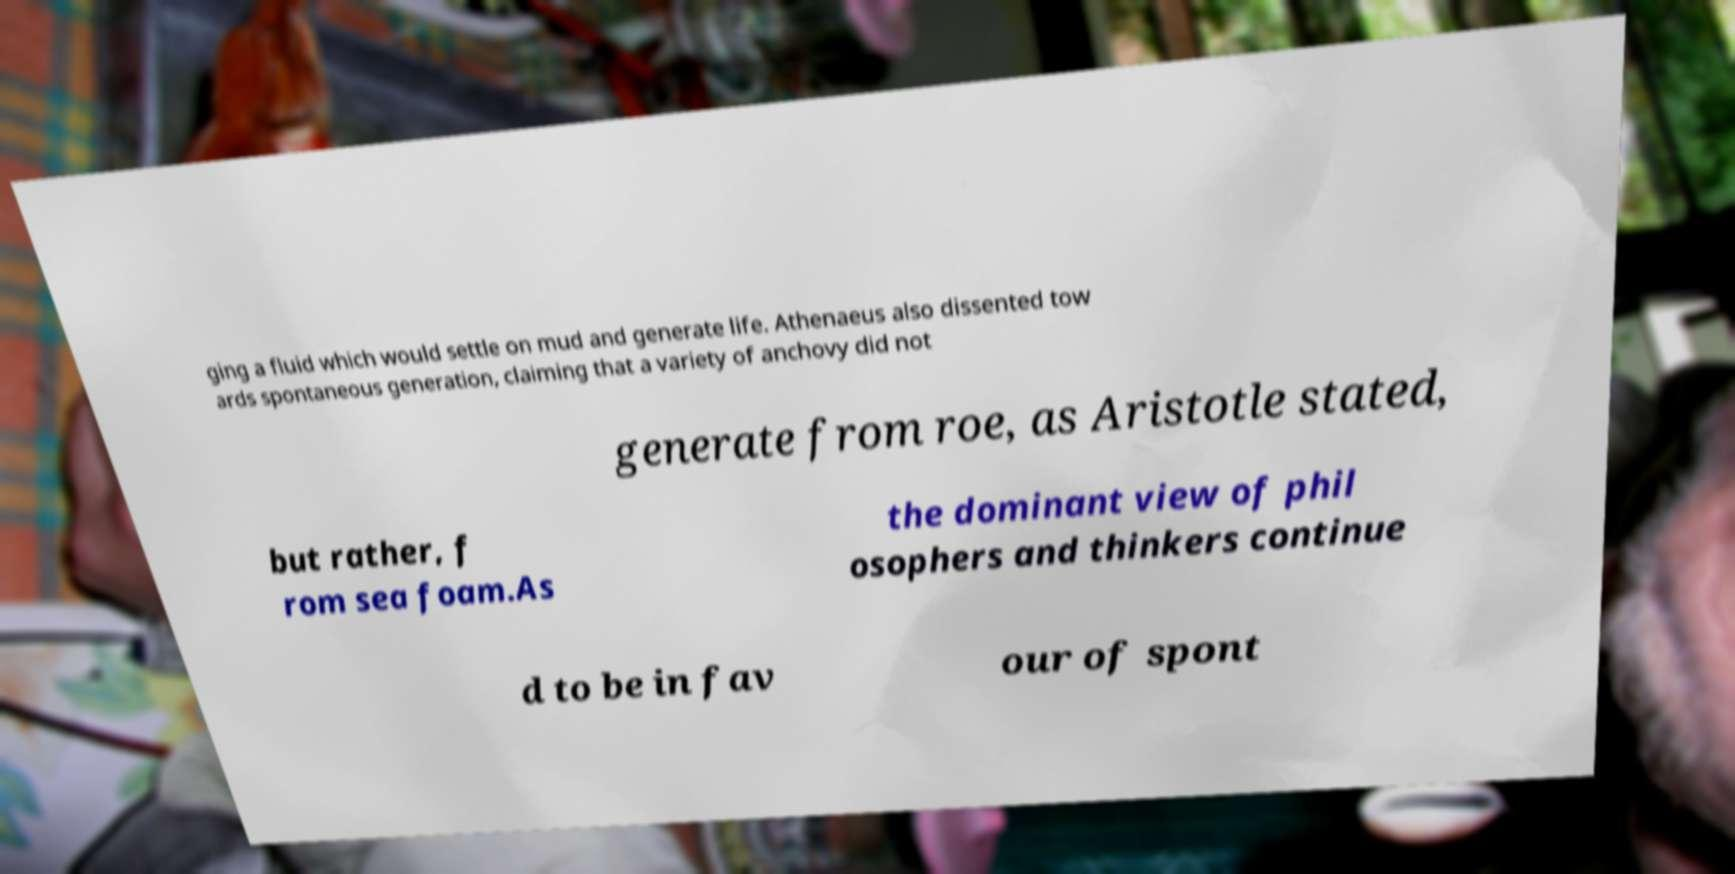Can you accurately transcribe the text from the provided image for me? ging a fluid which would settle on mud and generate life. Athenaeus also dissented tow ards spontaneous generation, claiming that a variety of anchovy did not generate from roe, as Aristotle stated, but rather, f rom sea foam.As the dominant view of phil osophers and thinkers continue d to be in fav our of spont 